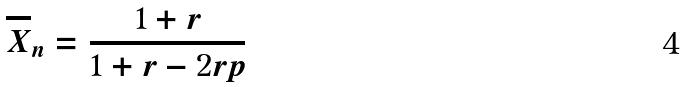<formula> <loc_0><loc_0><loc_500><loc_500>\overline { X } _ { n } = \frac { 1 + r } { 1 + r - 2 r p }</formula> 